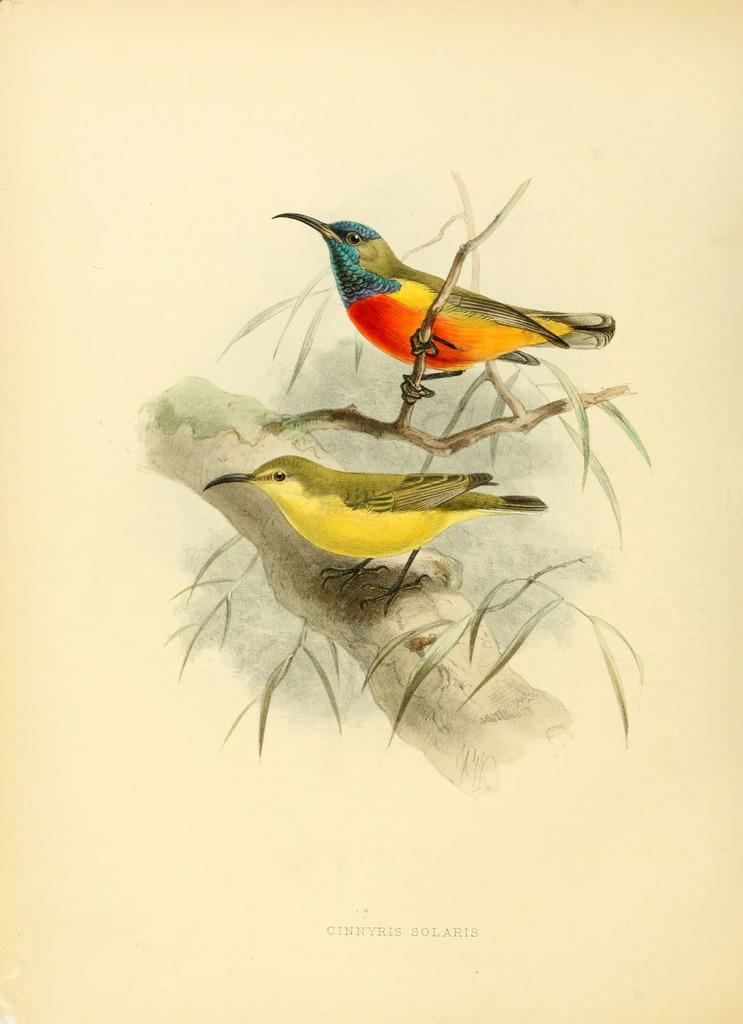What is the main subject of the image? There is a painting in the image. What can be seen in the painting? There is a bird standing on a stem and another bird standing on a branch of a tree in the painting. Where is the cannon located in the painting? There is no cannon present in the painting; it features two birds on a stem and a tree branch. What unit is responsible for maintaining the hall in the image? There is no mention of a hall or a unit in the image, as it only contains a painting with two birds. 